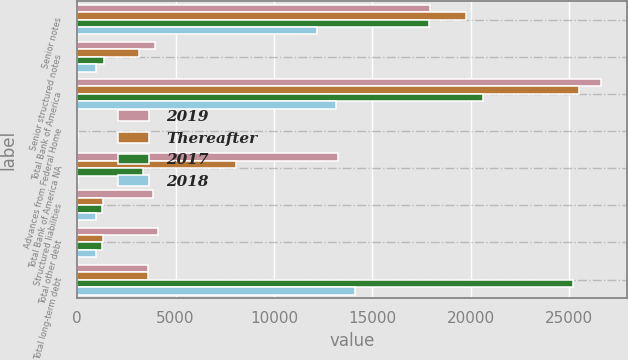Convert chart. <chart><loc_0><loc_0><loc_500><loc_500><stacked_bar_chart><ecel><fcel>Senior notes<fcel>Senior structured notes<fcel>Total Bank of America<fcel>Advances from Federal Home<fcel>Total Bank of America NA<fcel>Structured liabilities<fcel>Total other debt<fcel>Total long-term debt<nl><fcel>2019<fcel>17913<fcel>3931<fcel>26604<fcel>9<fcel>13253<fcel>3860<fcel>4107<fcel>3590<nl><fcel>Thereafter<fcel>19765<fcel>3137<fcel>25505<fcel>9<fcel>8060<fcel>1288<fcel>1315<fcel>3590<nl><fcel>2017<fcel>17858<fcel>1341<fcel>20630<fcel>14<fcel>3320<fcel>1261<fcel>1276<fcel>25226<nl><fcel>2018<fcel>12168<fcel>969<fcel>13137<fcel>12<fcel>22<fcel>977<fcel>977<fcel>14136<nl></chart> 